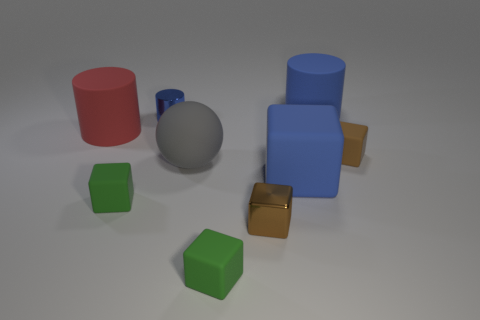Subtract all tiny green cubes. How many cubes are left? 3 Subtract all blue blocks. How many blocks are left? 4 Subtract 3 cubes. How many cubes are left? 2 Add 1 small matte objects. How many objects exist? 10 Subtract all blocks. How many objects are left? 4 Add 6 small brown objects. How many small brown objects exist? 8 Subtract 0 red spheres. How many objects are left? 9 Subtract all gray cylinders. Subtract all green balls. How many cylinders are left? 3 Subtract all yellow cylinders. How many yellow cubes are left? 0 Subtract all red things. Subtract all large red cylinders. How many objects are left? 7 